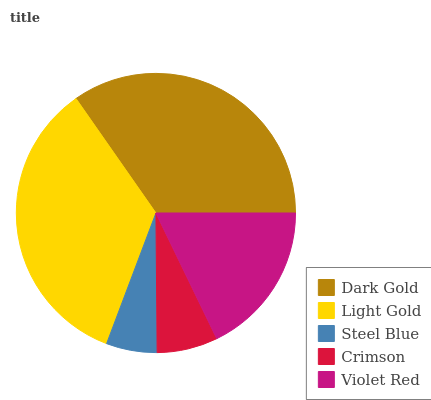Is Steel Blue the minimum?
Answer yes or no. Yes. Is Dark Gold the maximum?
Answer yes or no. Yes. Is Light Gold the minimum?
Answer yes or no. No. Is Light Gold the maximum?
Answer yes or no. No. Is Dark Gold greater than Light Gold?
Answer yes or no. Yes. Is Light Gold less than Dark Gold?
Answer yes or no. Yes. Is Light Gold greater than Dark Gold?
Answer yes or no. No. Is Dark Gold less than Light Gold?
Answer yes or no. No. Is Violet Red the high median?
Answer yes or no. Yes. Is Violet Red the low median?
Answer yes or no. Yes. Is Dark Gold the high median?
Answer yes or no. No. Is Crimson the low median?
Answer yes or no. No. 